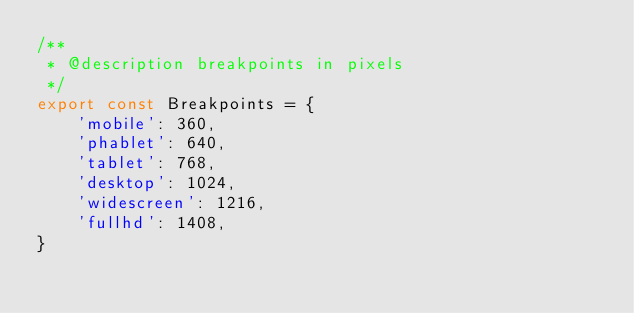<code> <loc_0><loc_0><loc_500><loc_500><_JavaScript_>/**
 * @description breakpoints in pixels
 */
export const Breakpoints = {
    'mobile': 360,
    'phablet': 640,
    'tablet': 768,
    'desktop': 1024,
    'widescreen': 1216,
    'fullhd': 1408,
}</code> 